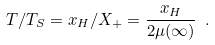Convert formula to latex. <formula><loc_0><loc_0><loc_500><loc_500>T / T _ { S } = x _ { H } / X _ { + } = \frac { x _ { H } } { 2 \mu ( \infty ) } \ .</formula> 